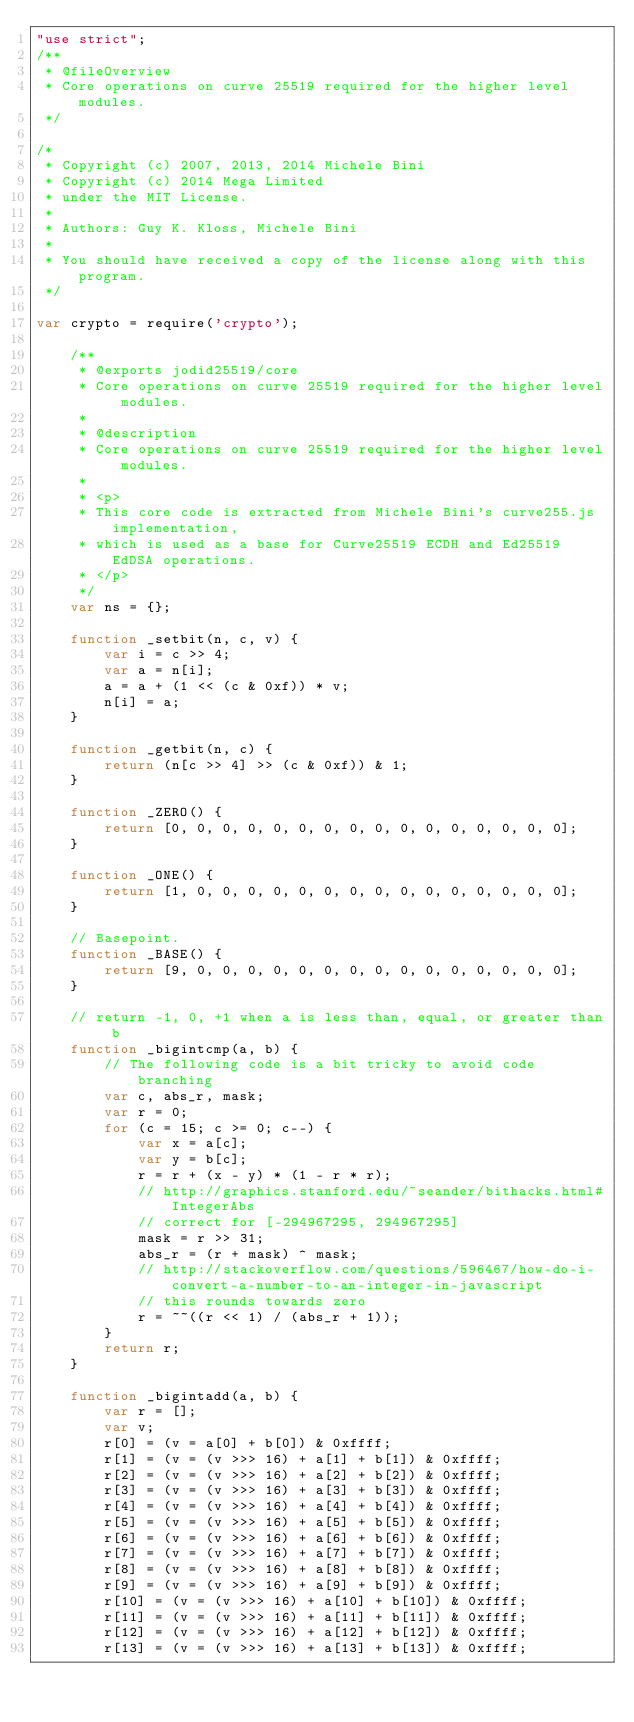Convert code to text. <code><loc_0><loc_0><loc_500><loc_500><_JavaScript_>"use strict";
/**
 * @fileOverview
 * Core operations on curve 25519 required for the higher level modules.
 */

/*
 * Copyright (c) 2007, 2013, 2014 Michele Bini
 * Copyright (c) 2014 Mega Limited
 * under the MIT License.
 *
 * Authors: Guy K. Kloss, Michele Bini
 *
 * You should have received a copy of the license along with this program.
 */

var crypto = require('crypto');

    /**
     * @exports jodid25519/core
     * Core operations on curve 25519 required for the higher level modules.
     *
     * @description
     * Core operations on curve 25519 required for the higher level modules.
     *
     * <p>
     * This core code is extracted from Michele Bini's curve255.js implementation,
     * which is used as a base for Curve25519 ECDH and Ed25519 EdDSA operations.
     * </p>
     */
    var ns = {};

    function _setbit(n, c, v) {
        var i = c >> 4;
        var a = n[i];
        a = a + (1 << (c & 0xf)) * v;
        n[i] = a;
    }

    function _getbit(n, c) {
        return (n[c >> 4] >> (c & 0xf)) & 1;
    }

    function _ZERO() {
        return [0, 0, 0, 0, 0, 0, 0, 0, 0, 0, 0, 0, 0, 0, 0, 0];
    }

    function _ONE() {
        return [1, 0, 0, 0, 0, 0, 0, 0, 0, 0, 0, 0, 0, 0, 0, 0];
    }

    // Basepoint.
    function _BASE() {
        return [9, 0, 0, 0, 0, 0, 0, 0, 0, 0, 0, 0, 0, 0, 0, 0];
    }

    // return -1, 0, +1 when a is less than, equal, or greater than b
    function _bigintcmp(a, b) {
        // The following code is a bit tricky to avoid code branching
        var c, abs_r, mask;
        var r = 0;
        for (c = 15; c >= 0; c--) {
            var x = a[c];
            var y = b[c];
            r = r + (x - y) * (1 - r * r);
            // http://graphics.stanford.edu/~seander/bithacks.html#IntegerAbs
            // correct for [-294967295, 294967295]
            mask = r >> 31;
            abs_r = (r + mask) ^ mask;
            // http://stackoverflow.com/questions/596467/how-do-i-convert-a-number-to-an-integer-in-javascript
            // this rounds towards zero
            r = ~~((r << 1) / (abs_r + 1));
        }
        return r;
    }

    function _bigintadd(a, b) {
        var r = [];
        var v;
        r[0] = (v = a[0] + b[0]) & 0xffff;
        r[1] = (v = (v >>> 16) + a[1] + b[1]) & 0xffff;
        r[2] = (v = (v >>> 16) + a[2] + b[2]) & 0xffff;
        r[3] = (v = (v >>> 16) + a[3] + b[3]) & 0xffff;
        r[4] = (v = (v >>> 16) + a[4] + b[4]) & 0xffff;
        r[5] = (v = (v >>> 16) + a[5] + b[5]) & 0xffff;
        r[6] = (v = (v >>> 16) + a[6] + b[6]) & 0xffff;
        r[7] = (v = (v >>> 16) + a[7] + b[7]) & 0xffff;
        r[8] = (v = (v >>> 16) + a[8] + b[8]) & 0xffff;
        r[9] = (v = (v >>> 16) + a[9] + b[9]) & 0xffff;
        r[10] = (v = (v >>> 16) + a[10] + b[10]) & 0xffff;
        r[11] = (v = (v >>> 16) + a[11] + b[11]) & 0xffff;
        r[12] = (v = (v >>> 16) + a[12] + b[12]) & 0xffff;
        r[13] = (v = (v >>> 16) + a[13] + b[13]) & 0xffff;</code> 